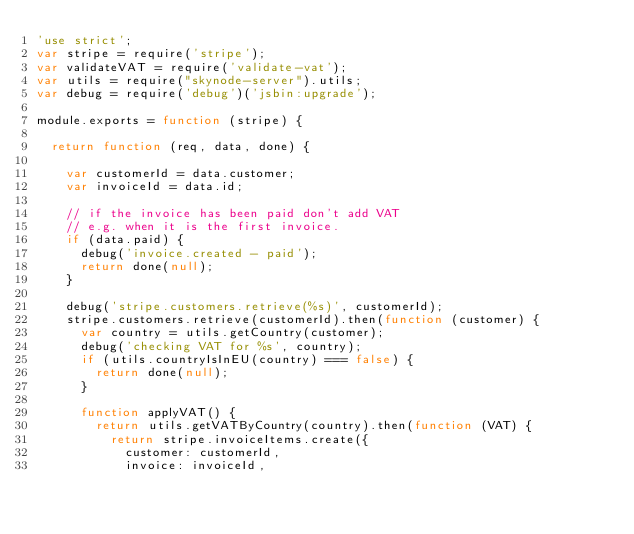<code> <loc_0><loc_0><loc_500><loc_500><_JavaScript_>'use strict';
var stripe = require('stripe');
var validateVAT = require('validate-vat');
var utils = require("skynode-server").utils;
var debug = require('debug')('jsbin:upgrade');

module.exports = function (stripe) {

  return function (req, data, done) {

    var customerId = data.customer;
    var invoiceId = data.id;

    // if the invoice has been paid don't add VAT
    // e.g. when it is the first invoice.
    if (data.paid) {
      debug('invoice.created - paid');
      return done(null);
    }

    debug('stripe.customers.retrieve(%s)', customerId);
    stripe.customers.retrieve(customerId).then(function (customer) {
      var country = utils.getCountry(customer);
      debug('checking VAT for %s', country);
      if (utils.countryIsInEU(country) === false) {
        return done(null);
      }

      function applyVAT() {
        return utils.getVATByCountry(country).then(function (VAT) {
          return stripe.invoiceItems.create({
            customer: customerId,
            invoice: invoiceId,</code> 